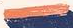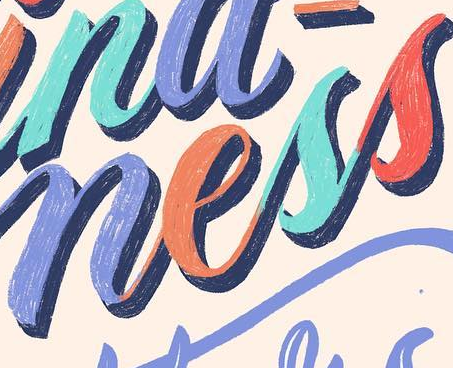Identify the words shown in these images in order, separated by a semicolon. -; ness 